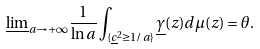Convert formula to latex. <formula><loc_0><loc_0><loc_500><loc_500>\underline { \lim } _ { a \rightarrow + \infty } \frac { 1 } { \ln a } \int _ { \{ \underline { c } ^ { 2 } \geq 1 / a \} } \underline { \gamma } ( z ) d \mu ( z ) = \theta .</formula> 